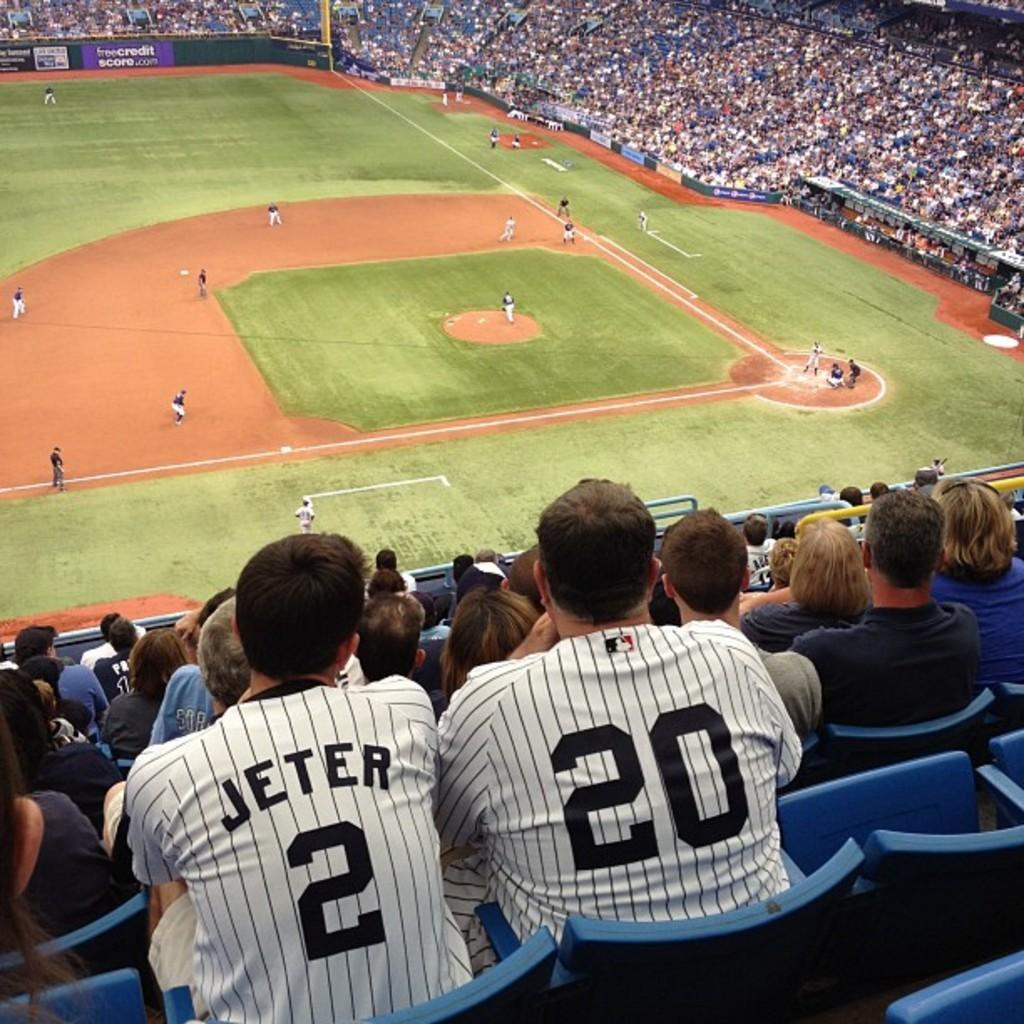<image>
Describe the image concisely. Two baseball fans sit high up in a stadium wearing number 2 and 20 jerseys. 